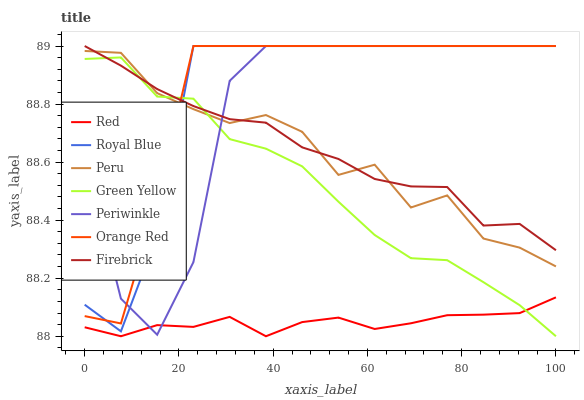Does Red have the minimum area under the curve?
Answer yes or no. Yes. Does Orange Red have the maximum area under the curve?
Answer yes or no. Yes. Does Royal Blue have the minimum area under the curve?
Answer yes or no. No. Does Royal Blue have the maximum area under the curve?
Answer yes or no. No. Is Red the smoothest?
Answer yes or no. Yes. Is Periwinkle the roughest?
Answer yes or no. Yes. Is Royal Blue the smoothest?
Answer yes or no. No. Is Royal Blue the roughest?
Answer yes or no. No. Does Green Yellow have the lowest value?
Answer yes or no. Yes. Does Royal Blue have the lowest value?
Answer yes or no. No. Does Orange Red have the highest value?
Answer yes or no. Yes. Does Peru have the highest value?
Answer yes or no. No. Is Red less than Peru?
Answer yes or no. Yes. Is Orange Red greater than Red?
Answer yes or no. Yes. Does Green Yellow intersect Royal Blue?
Answer yes or no. Yes. Is Green Yellow less than Royal Blue?
Answer yes or no. No. Is Green Yellow greater than Royal Blue?
Answer yes or no. No. Does Red intersect Peru?
Answer yes or no. No. 